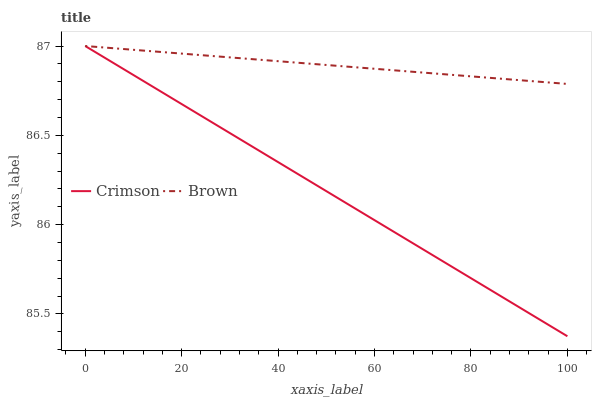Does Crimson have the minimum area under the curve?
Answer yes or no. Yes. Does Brown have the maximum area under the curve?
Answer yes or no. Yes. Does Brown have the minimum area under the curve?
Answer yes or no. No. Is Brown the smoothest?
Answer yes or no. Yes. Is Crimson the roughest?
Answer yes or no. Yes. Is Brown the roughest?
Answer yes or no. No. Does Crimson have the lowest value?
Answer yes or no. Yes. Does Brown have the lowest value?
Answer yes or no. No. Does Brown have the highest value?
Answer yes or no. Yes. Does Crimson intersect Brown?
Answer yes or no. Yes. Is Crimson less than Brown?
Answer yes or no. No. Is Crimson greater than Brown?
Answer yes or no. No. 